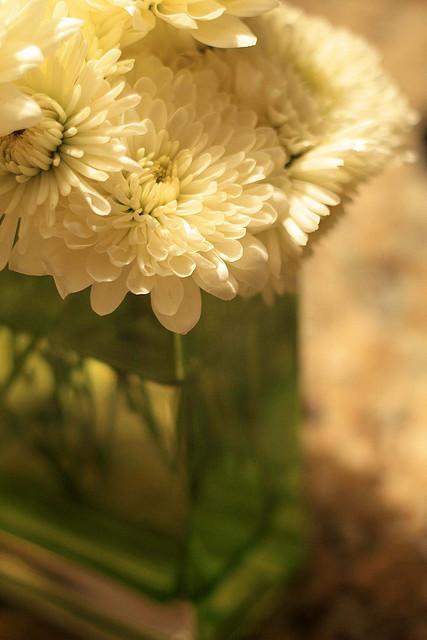What shaped vase are the flowers in?
Quick response, please. Square. Is there an insect inside the flower?
Answer briefly. No. Are the flowers cut?
Concise answer only. Yes. 